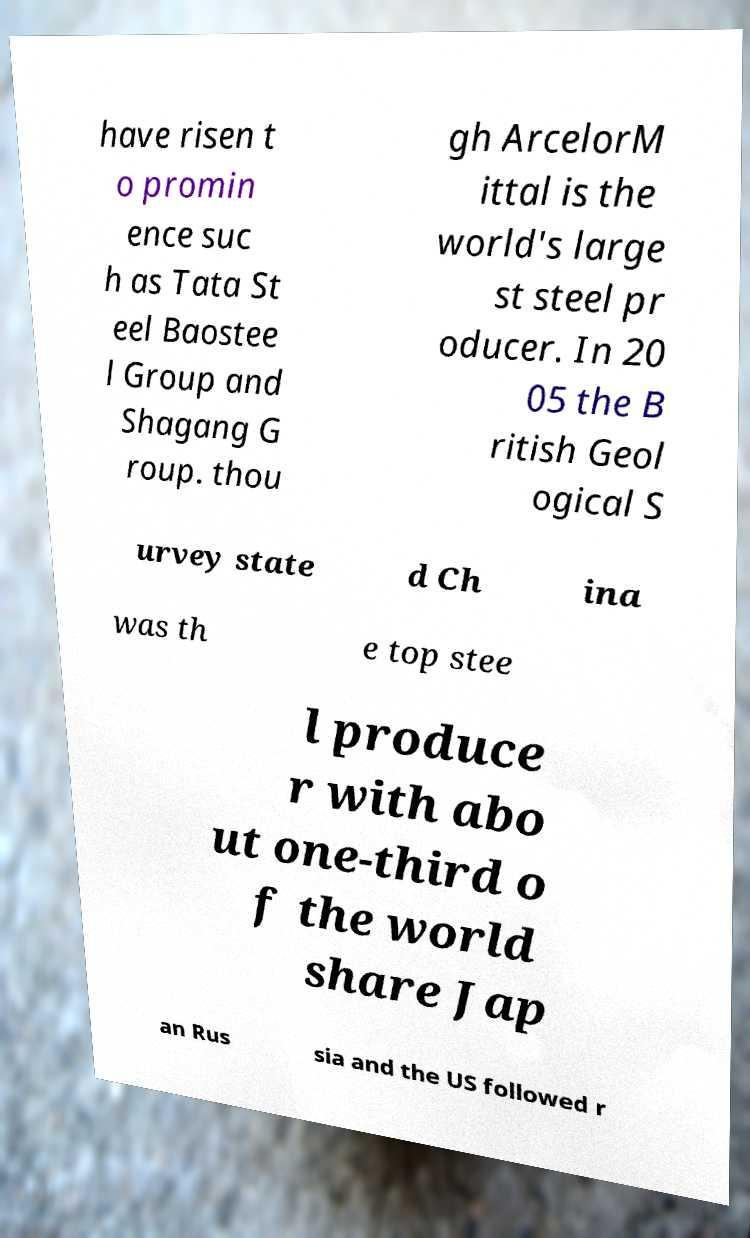Can you accurately transcribe the text from the provided image for me? have risen t o promin ence suc h as Tata St eel Baostee l Group and Shagang G roup. thou gh ArcelorM ittal is the world's large st steel pr oducer. In 20 05 the B ritish Geol ogical S urvey state d Ch ina was th e top stee l produce r with abo ut one-third o f the world share Jap an Rus sia and the US followed r 